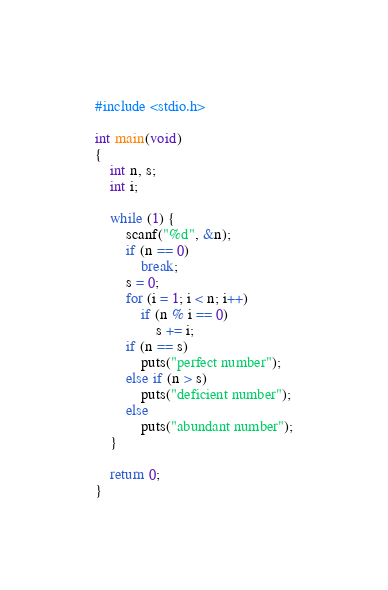Convert code to text. <code><loc_0><loc_0><loc_500><loc_500><_C_>#include <stdio.h>

int main(void)
{
	int n, s;
	int i;

	while (1) {
		scanf("%d", &n);
		if (n == 0)
			break;
		s = 0;
		for (i = 1; i < n; i++)
			if (n % i == 0)
				s += i;
		if (n == s)
			puts("perfect number");
		else if (n > s)
			puts("deficient number");
		else
			puts("abundant number");
	}

	return 0;
}</code> 